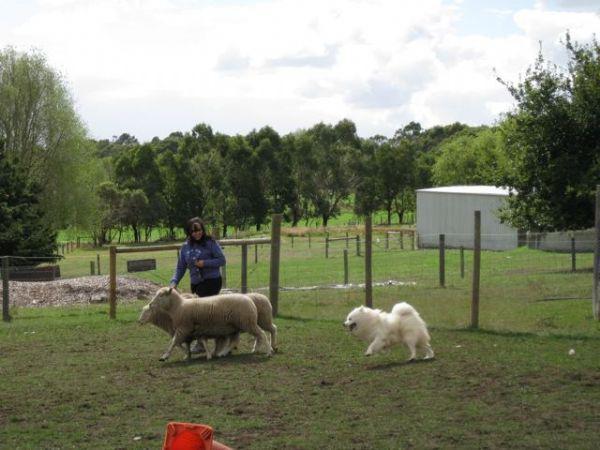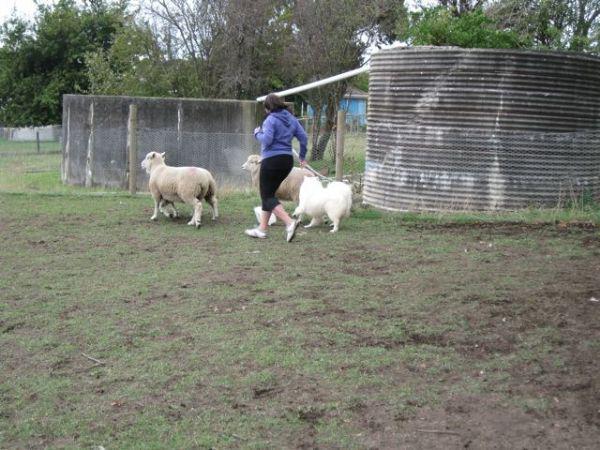The first image is the image on the left, the second image is the image on the right. Assess this claim about the two images: "A girl wearing a blue sweatshirt is with a white dog and some sheep.". Correct or not? Answer yes or no. Yes. 